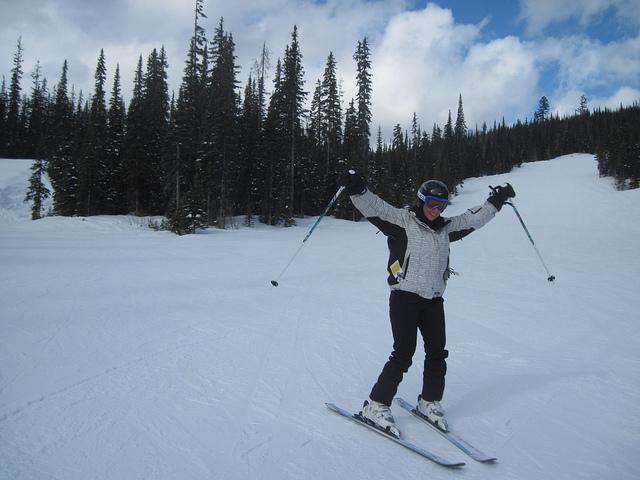What is the person doing?
Give a very brief answer. Skiing. Where can you buy skis?
Answer briefly. Sporting goods store. What color is her coat?
Concise answer only. White and black. Is the snow deep?
Give a very brief answer. Yes. 